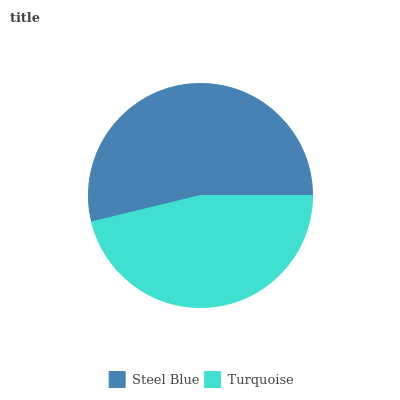Is Turquoise the minimum?
Answer yes or no. Yes. Is Steel Blue the maximum?
Answer yes or no. Yes. Is Turquoise the maximum?
Answer yes or no. No. Is Steel Blue greater than Turquoise?
Answer yes or no. Yes. Is Turquoise less than Steel Blue?
Answer yes or no. Yes. Is Turquoise greater than Steel Blue?
Answer yes or no. No. Is Steel Blue less than Turquoise?
Answer yes or no. No. Is Steel Blue the high median?
Answer yes or no. Yes. Is Turquoise the low median?
Answer yes or no. Yes. Is Turquoise the high median?
Answer yes or no. No. Is Steel Blue the low median?
Answer yes or no. No. 